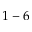<formula> <loc_0><loc_0><loc_500><loc_500>1 - 6</formula> 